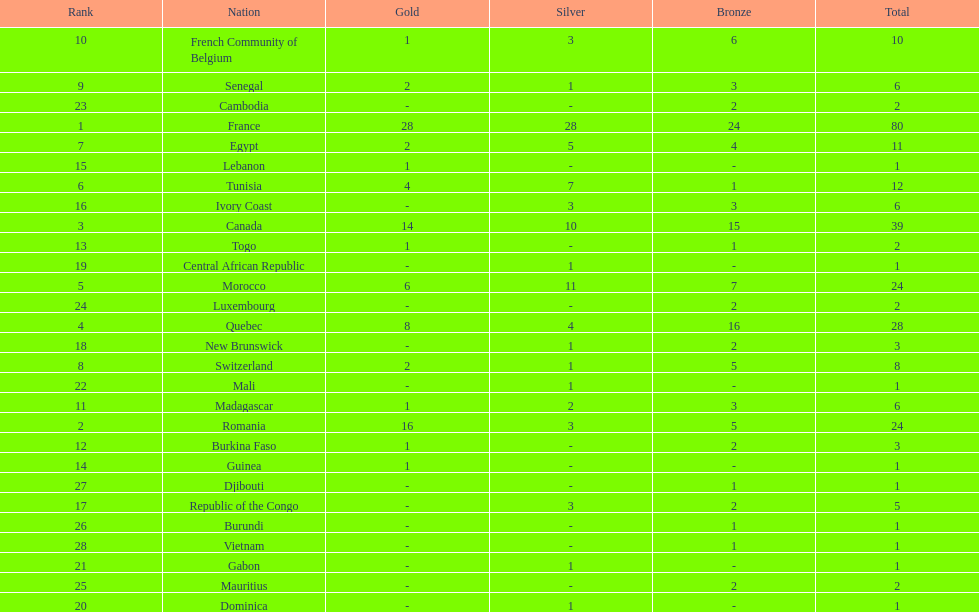Who placed in first according to medals? France. 